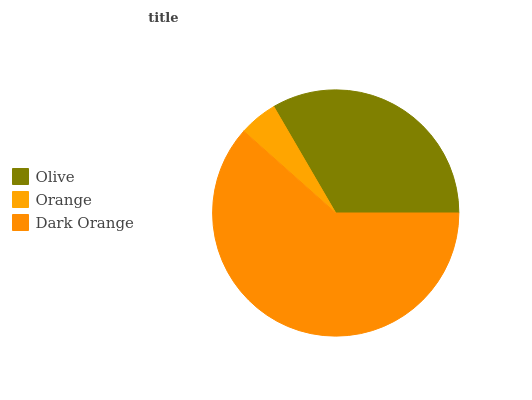Is Orange the minimum?
Answer yes or no. Yes. Is Dark Orange the maximum?
Answer yes or no. Yes. Is Dark Orange the minimum?
Answer yes or no. No. Is Orange the maximum?
Answer yes or no. No. Is Dark Orange greater than Orange?
Answer yes or no. Yes. Is Orange less than Dark Orange?
Answer yes or no. Yes. Is Orange greater than Dark Orange?
Answer yes or no. No. Is Dark Orange less than Orange?
Answer yes or no. No. Is Olive the high median?
Answer yes or no. Yes. Is Olive the low median?
Answer yes or no. Yes. Is Orange the high median?
Answer yes or no. No. Is Orange the low median?
Answer yes or no. No. 